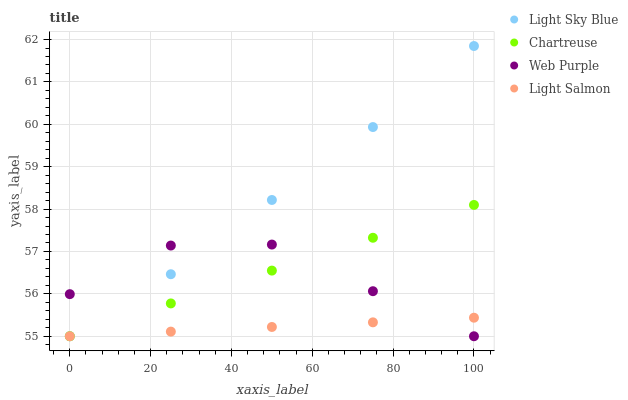Does Light Salmon have the minimum area under the curve?
Answer yes or no. Yes. Does Light Sky Blue have the maximum area under the curve?
Answer yes or no. Yes. Does Web Purple have the minimum area under the curve?
Answer yes or no. No. Does Web Purple have the maximum area under the curve?
Answer yes or no. No. Is Light Salmon the smoothest?
Answer yes or no. Yes. Is Web Purple the roughest?
Answer yes or no. Yes. Is Light Sky Blue the smoothest?
Answer yes or no. No. Is Light Sky Blue the roughest?
Answer yes or no. No. Does Chartreuse have the lowest value?
Answer yes or no. Yes. Does Light Sky Blue have the highest value?
Answer yes or no. Yes. Does Web Purple have the highest value?
Answer yes or no. No. Does Light Salmon intersect Light Sky Blue?
Answer yes or no. Yes. Is Light Salmon less than Light Sky Blue?
Answer yes or no. No. Is Light Salmon greater than Light Sky Blue?
Answer yes or no. No. 